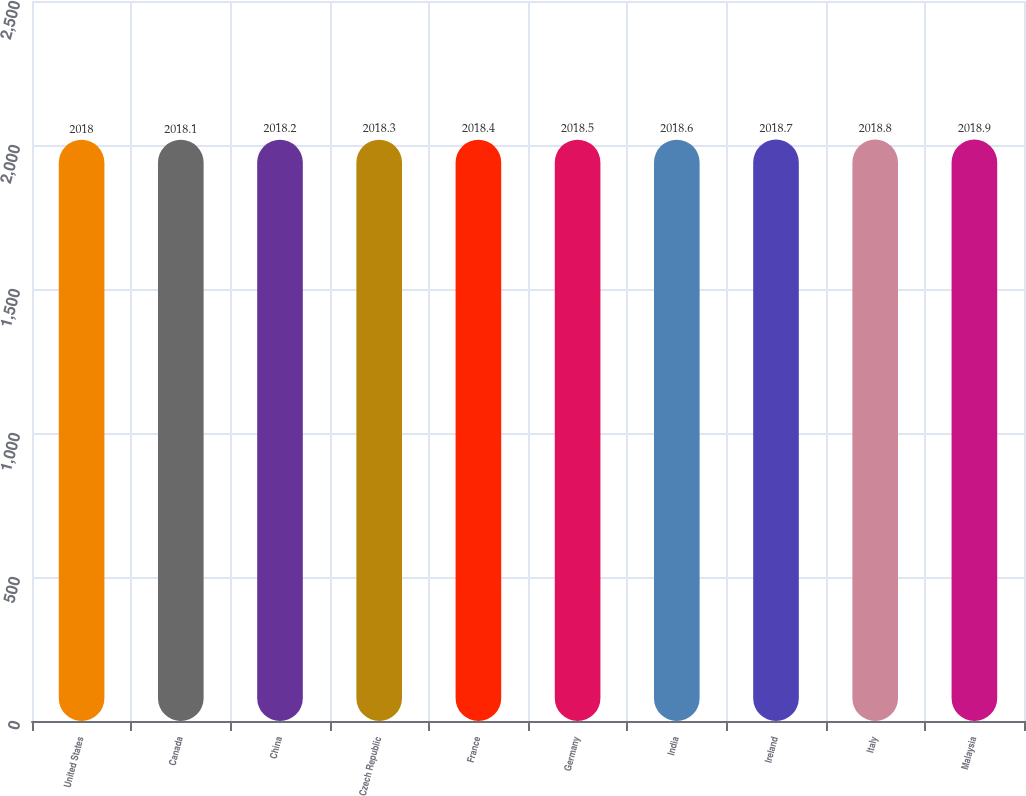<chart> <loc_0><loc_0><loc_500><loc_500><bar_chart><fcel>United States<fcel>Canada<fcel>China<fcel>Czech Republic<fcel>France<fcel>Germany<fcel>India<fcel>Ireland<fcel>Italy<fcel>Malaysia<nl><fcel>2018<fcel>2018.1<fcel>2018.2<fcel>2018.3<fcel>2018.4<fcel>2018.5<fcel>2018.6<fcel>2018.7<fcel>2018.8<fcel>2018.9<nl></chart> 